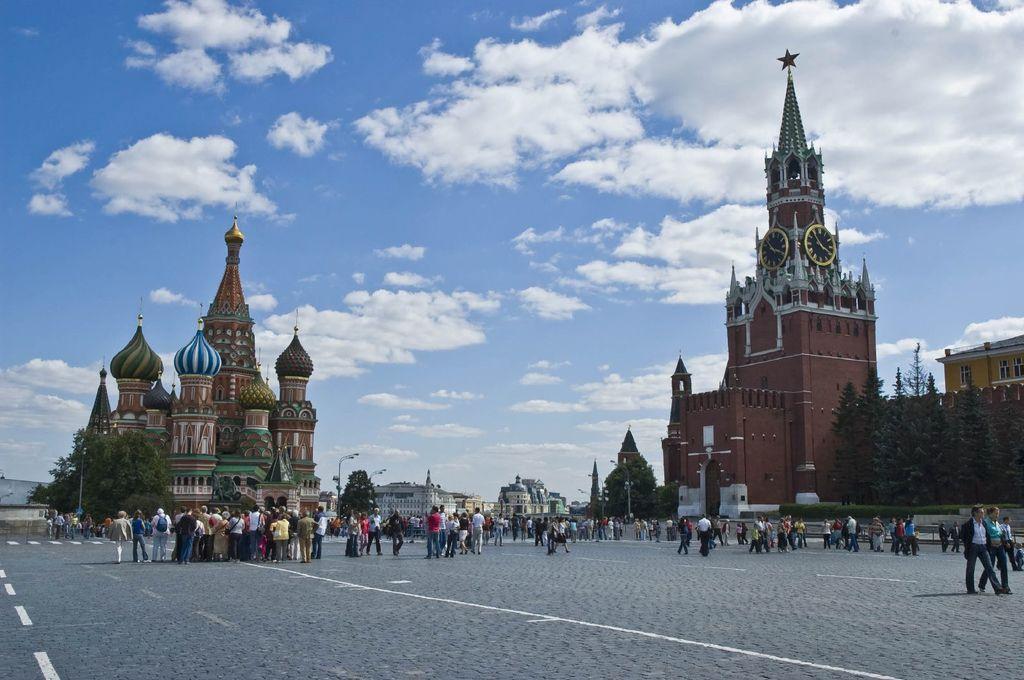Can you describe this image briefly? In this image I can see two forts , in front of forts I can see crowd of people visible on road , in the middle I can see two buildings and in front of fort I can see trees ,at the top I can see the sky. 